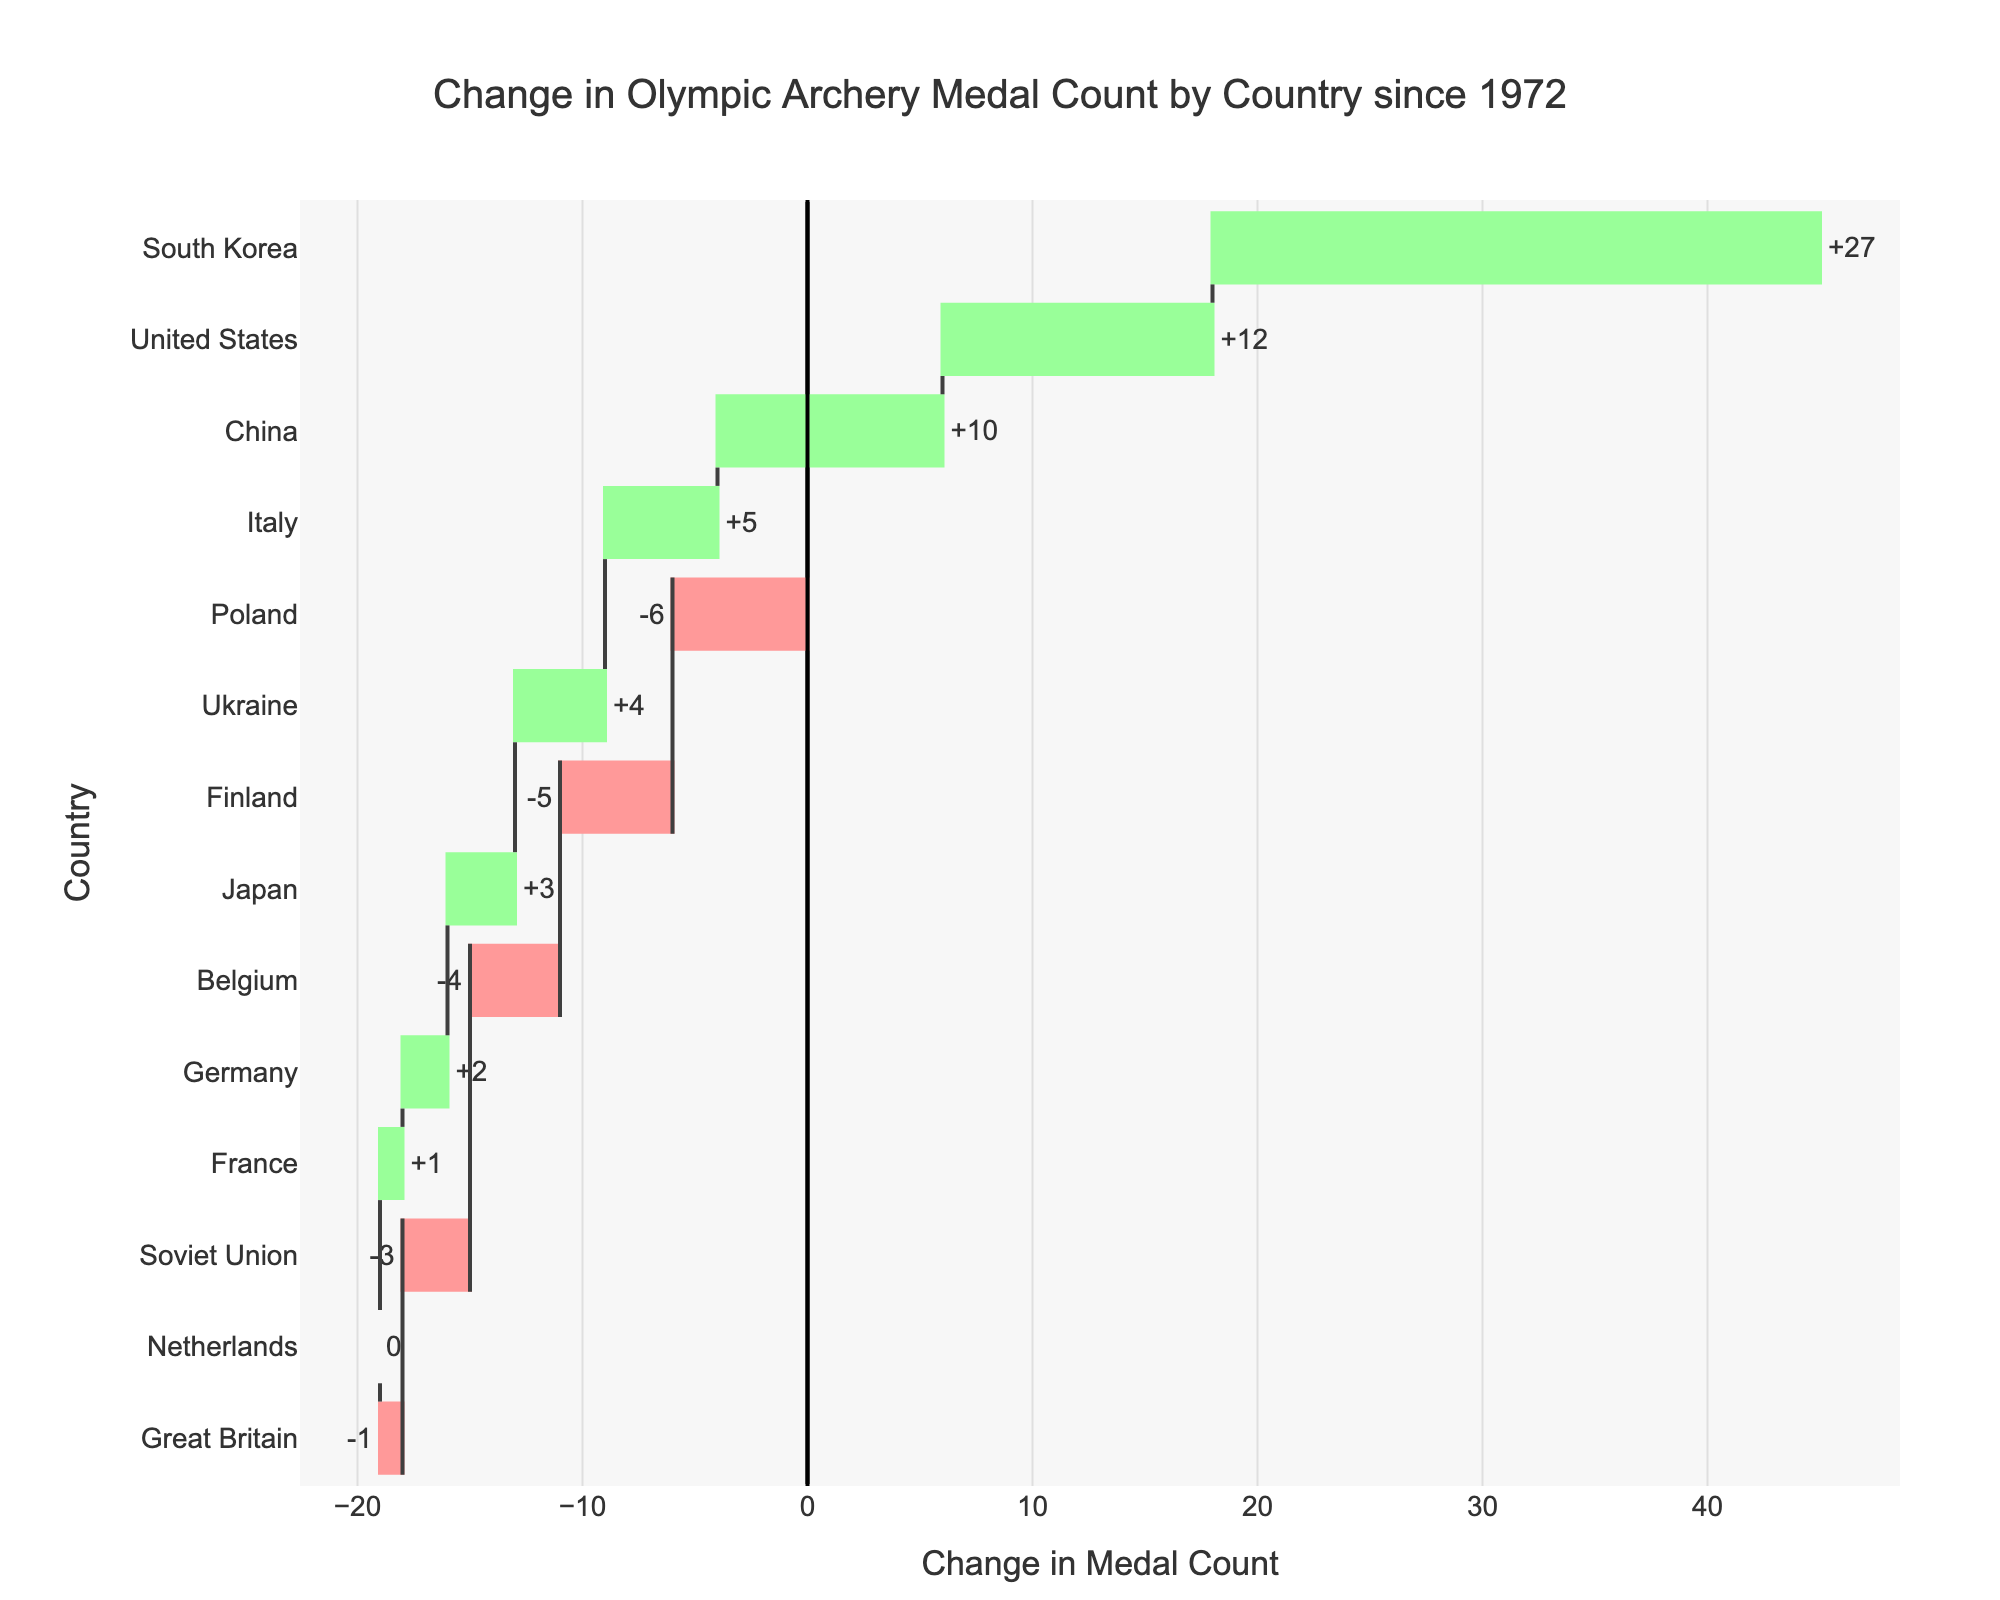What's the title of the chart? The title of the chart is usually placed at the top and is designed to provide a summary of what the chart is displaying. In this case, the title reads "Change in Olympic Archery Medal Count by Country since 1972."
Answer: Change in Olympic Archery Medal Count by Country since 1972 Which country has the largest positive change in medal count? The country with the largest positive change can be identified by looking for the bar with the greatest positive measure. According to the chart, South Korea stands out significantly with the largest positive change.
Answer: South Korea How many countries showed an increase in their medal counts? To find the number of countries with increased medal counts, count the bars that extend to the positive side (towards the right) of the zero line in the waterfall chart.
Answer: 7 Which country experienced the largest decrease in their medal count? To identify the country with the largest decrease, look at the bars on the negative side (left) of the zero line and find the one with the greatest negative value. According to the chart, Poland experienced the largest decrease.
Answer: Poland What is the total increase in medal counts from all countries combined? The total increase can be calculated by summing the positive changes: (+27) + (+12) + (+10) + (+5) + (+4) + (+3) + (+2) + (+1). So the total increase is 64 medals.
Answer: 64 What is the net change in the total medal count across all countries? To find the net change, sum the increases and decreases. The total positive change is 64 and the total negative change is (-19). Thus, the net change is 64 + (-19) = 45.
Answer: 45 How many countries have no change in their medal count? Countries with no change will have bars with a height of zero. According to the chart, only the Netherlands has zero change.
Answer: 1 Compare the changes in medal counts between the United States and Italy. To compare, refer to their respective bars. The United States has a positive change of +12 while Italy has a change of +5. The United States has a higher increase compared to Italy.
Answer: The United States has a larger increase What colors are used to indicate increasing and decreasing changes in the chart? In waterfall charts, colors distinguish the type of change. The increasing changes are shown in green, while the decreasing changes are shown in red.
Answer: Green for increasing, red for decreasing Does any country show a zero change in its medal count? If yes, which one? Look for a bar that meets the zero line without extending positively or negatively. According to the chart, the Netherlands shows zero change in its medal count.
Answer: The Netherlands 